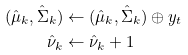Convert formula to latex. <formula><loc_0><loc_0><loc_500><loc_500>( \hat { \mu } _ { k } , \hat { \Sigma } _ { k } ) & \leftarrow ( \hat { \mu } _ { k } , \hat { \Sigma } _ { k } ) \oplus y _ { t } \\ \hat { \nu } _ { k } & \leftarrow \hat { \nu } _ { k } + 1</formula> 